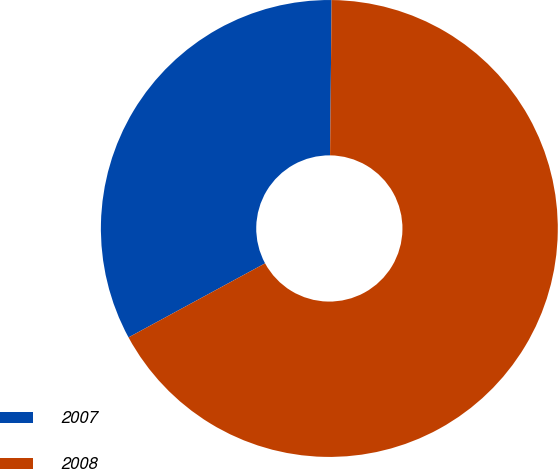Convert chart to OTSL. <chart><loc_0><loc_0><loc_500><loc_500><pie_chart><fcel>2007<fcel>2008<nl><fcel>33.07%<fcel>66.93%<nl></chart> 